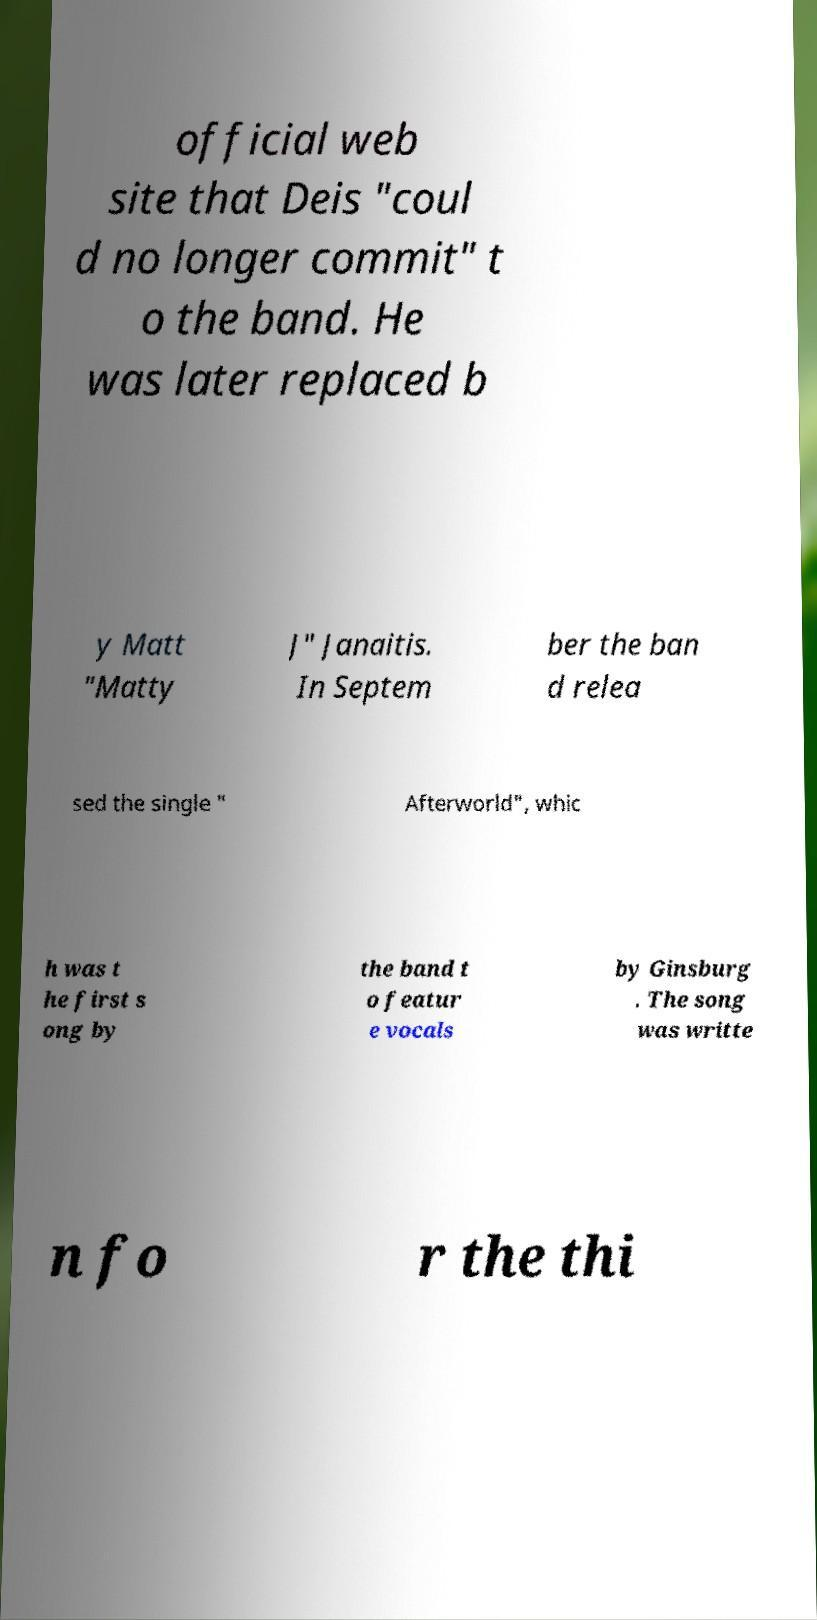What messages or text are displayed in this image? I need them in a readable, typed format. official web site that Deis "coul d no longer commit" t o the band. He was later replaced b y Matt "Matty J" Janaitis. In Septem ber the ban d relea sed the single " Afterworld", whic h was t he first s ong by the band t o featur e vocals by Ginsburg . The song was writte n fo r the thi 